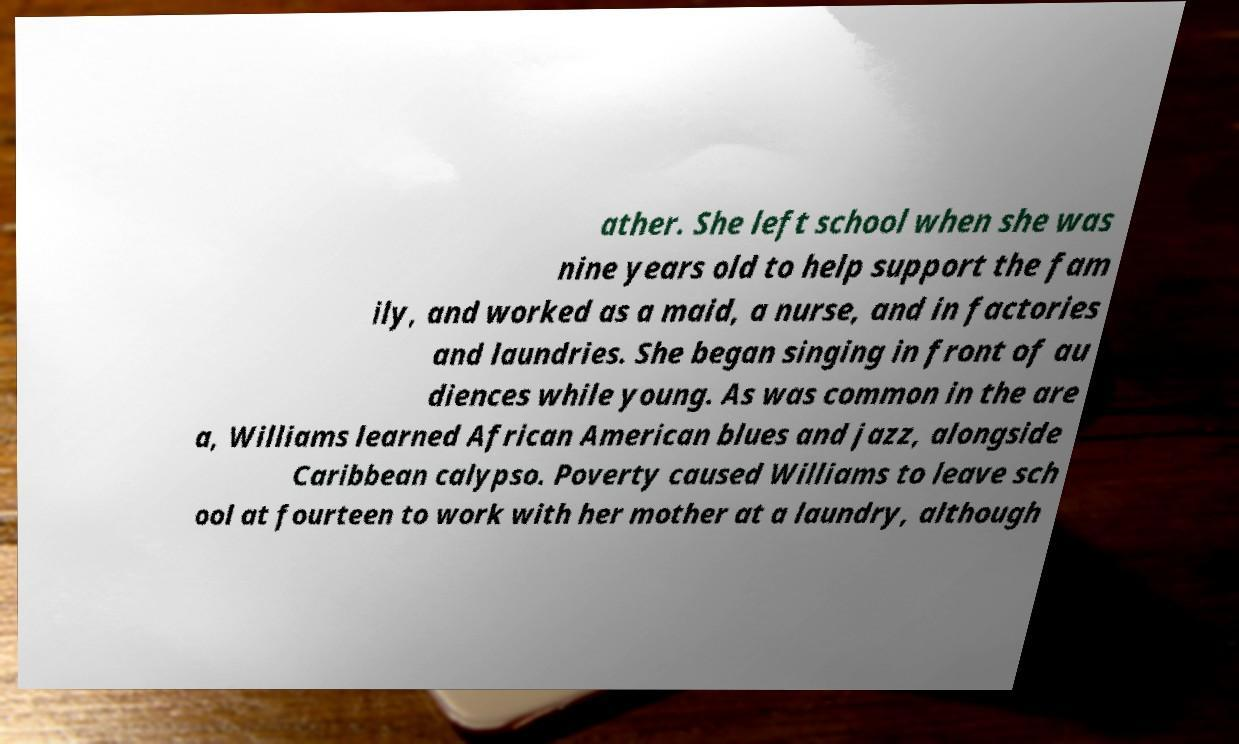For documentation purposes, I need the text within this image transcribed. Could you provide that? ather. She left school when she was nine years old to help support the fam ily, and worked as a maid, a nurse, and in factories and laundries. She began singing in front of au diences while young. As was common in the are a, Williams learned African American blues and jazz, alongside Caribbean calypso. Poverty caused Williams to leave sch ool at fourteen to work with her mother at a laundry, although 